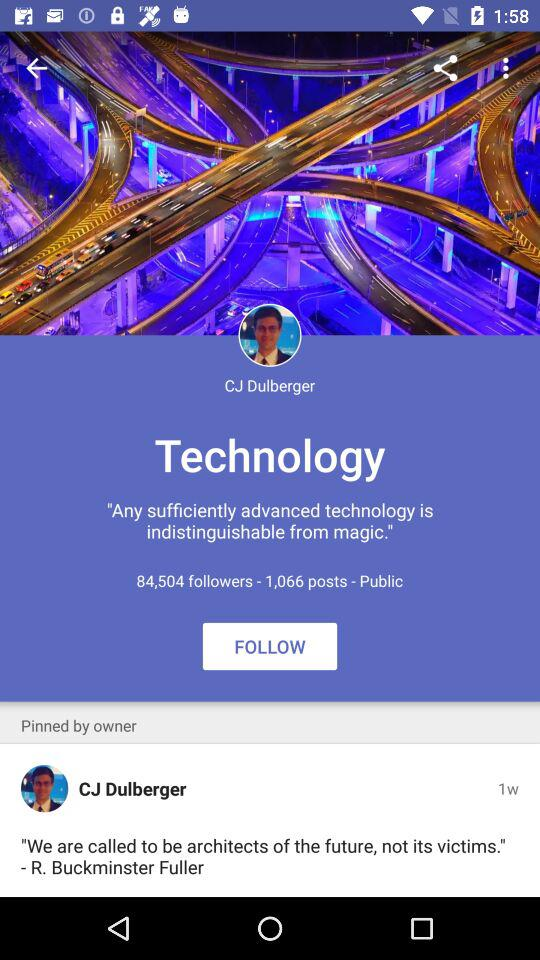When did the CJ Dulberger pinned?
When the provided information is insufficient, respond with <no answer>. <no answer> 